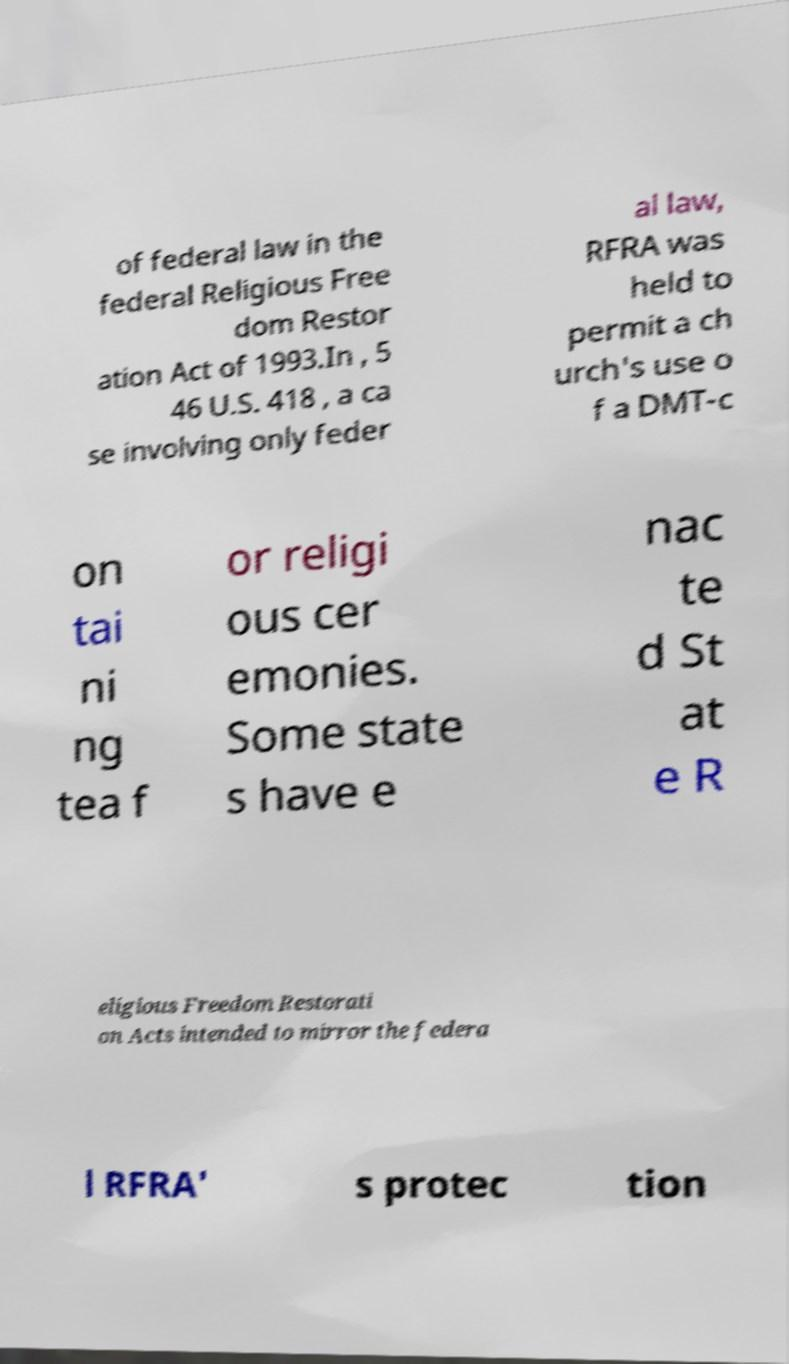Can you accurately transcribe the text from the provided image for me? of federal law in the federal Religious Free dom Restor ation Act of 1993.In , 5 46 U.S. 418 , a ca se involving only feder al law, RFRA was held to permit a ch urch's use o f a DMT-c on tai ni ng tea f or religi ous cer emonies. Some state s have e nac te d St at e R eligious Freedom Restorati on Acts intended to mirror the federa l RFRA' s protec tion 